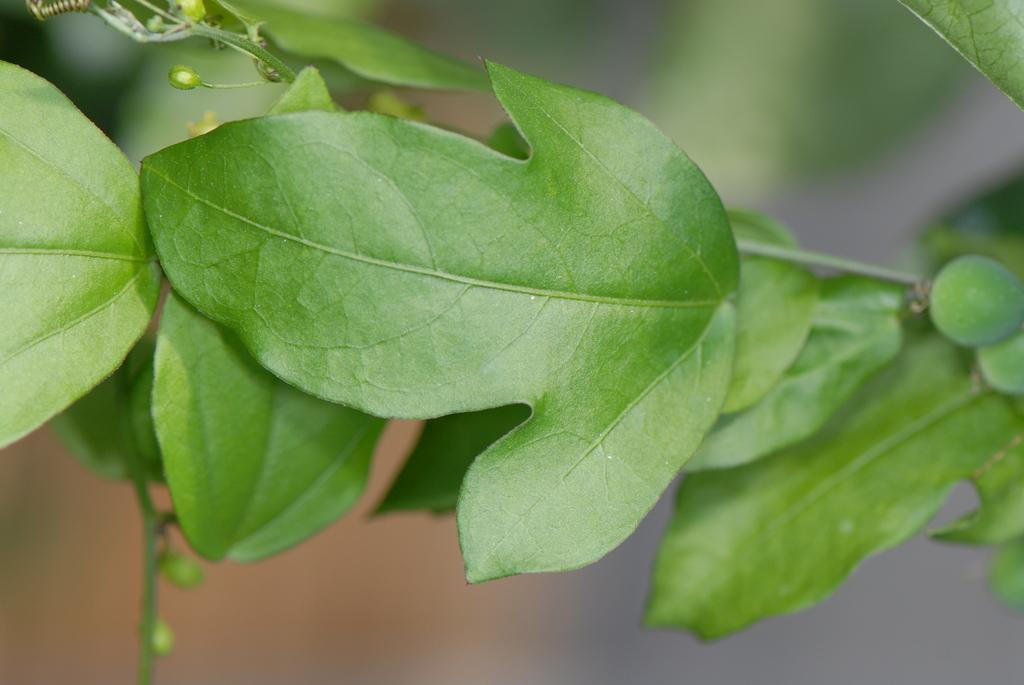What type of plant is depicted in the image? There are leaves on a stem in the image. Can you describe the background of the image? The background of the image is blurry. How many boats can be seen sailing in the background of the image? There are no boats visible in the image; the background is blurry and does not show any boats. What finger is shown pointing at the leaves in the image? There are no fingers or hands visible in the image; it only shows leaves on a stem and a blurry background. 